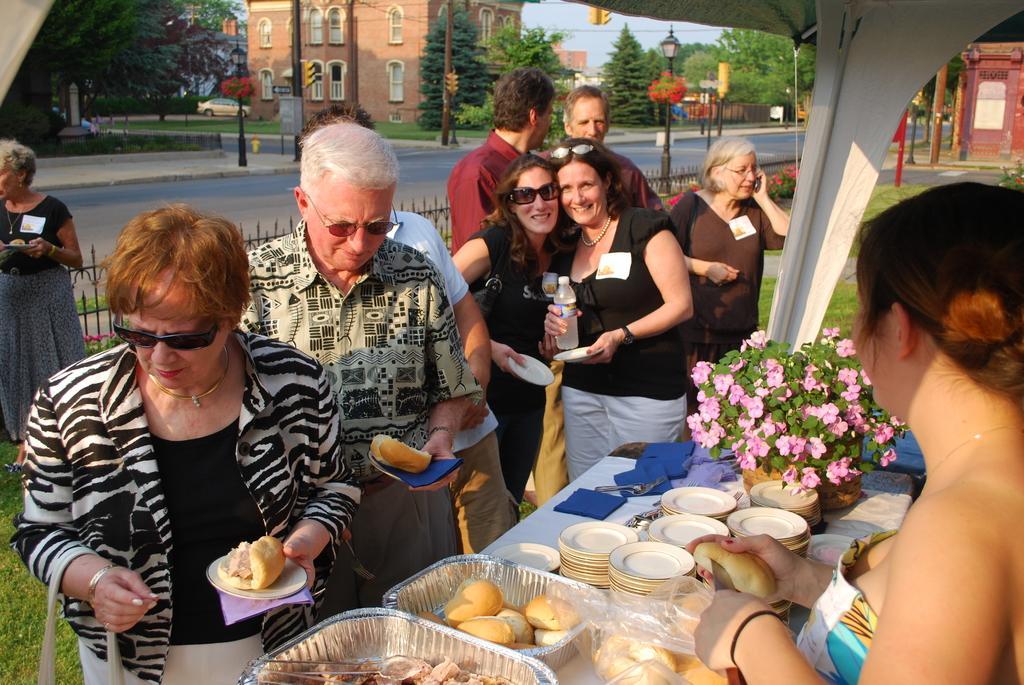In one or two sentences, can you explain what this image depicts? In this picture we can see a group of people holding some food items in their hands and in front of them there is a table on which there are some plates, food items and a small plant and we can see some trees, cars and buildings around them. 